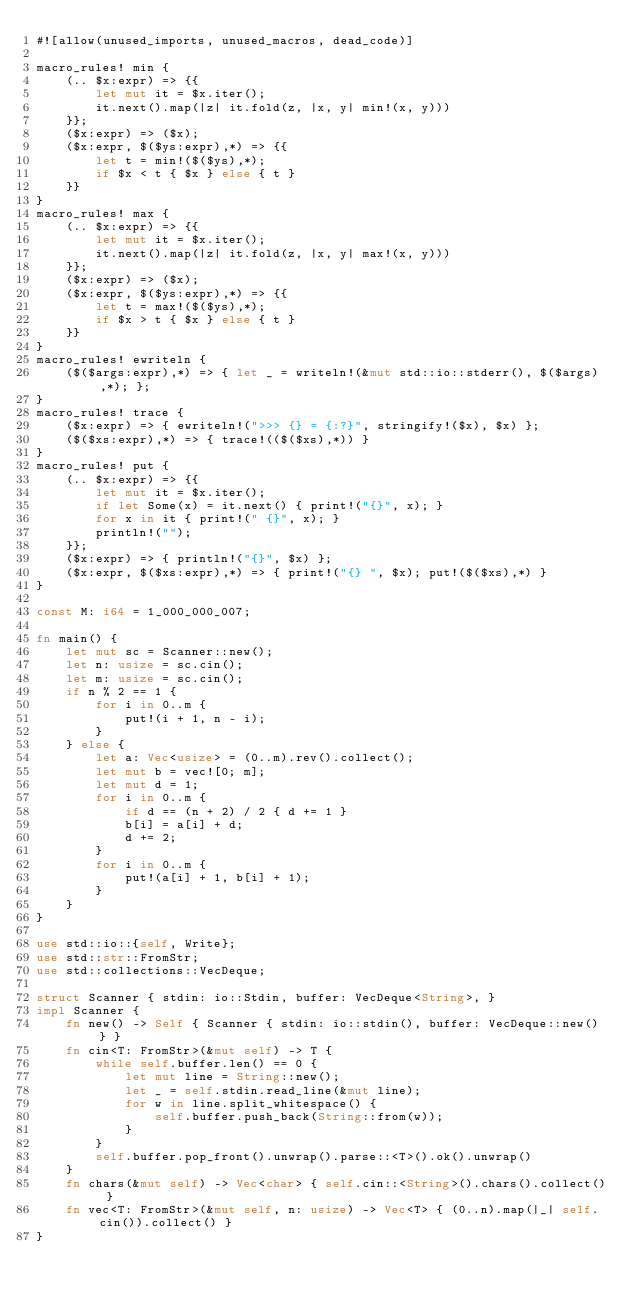Convert code to text. <code><loc_0><loc_0><loc_500><loc_500><_Rust_>#![allow(unused_imports, unused_macros, dead_code)]

macro_rules! min {
    (.. $x:expr) => {{
        let mut it = $x.iter();
        it.next().map(|z| it.fold(z, |x, y| min!(x, y)))
    }};
    ($x:expr) => ($x);
    ($x:expr, $($ys:expr),*) => {{
        let t = min!($($ys),*);
        if $x < t { $x } else { t }
    }}
}
macro_rules! max {
    (.. $x:expr) => {{
        let mut it = $x.iter();
        it.next().map(|z| it.fold(z, |x, y| max!(x, y)))
    }};
    ($x:expr) => ($x);
    ($x:expr, $($ys:expr),*) => {{
        let t = max!($($ys),*);
        if $x > t { $x } else { t }
    }}
}
macro_rules! ewriteln {
    ($($args:expr),*) => { let _ = writeln!(&mut std::io::stderr(), $($args),*); };
}
macro_rules! trace {
    ($x:expr) => { ewriteln!(">>> {} = {:?}", stringify!($x), $x) };
    ($($xs:expr),*) => { trace!(($($xs),*)) }
}
macro_rules! put {
    (.. $x:expr) => {{
        let mut it = $x.iter();
        if let Some(x) = it.next() { print!("{}", x); }
        for x in it { print!(" {}", x); }
        println!("");
    }};
    ($x:expr) => { println!("{}", $x) };
    ($x:expr, $($xs:expr),*) => { print!("{} ", $x); put!($($xs),*) }
}

const M: i64 = 1_000_000_007;

fn main() {
    let mut sc = Scanner::new();
    let n: usize = sc.cin();
    let m: usize = sc.cin();
    if n % 2 == 1 {
        for i in 0..m {
            put!(i + 1, n - i);
        }
    } else {
        let a: Vec<usize> = (0..m).rev().collect();
        let mut b = vec![0; m];
        let mut d = 1;
        for i in 0..m {
            if d == (n + 2) / 2 { d += 1 }
            b[i] = a[i] + d;
            d += 2;
        }
        for i in 0..m {
            put!(a[i] + 1, b[i] + 1);
        }
    }
}

use std::io::{self, Write};
use std::str::FromStr;
use std::collections::VecDeque;

struct Scanner { stdin: io::Stdin, buffer: VecDeque<String>, }
impl Scanner {
    fn new() -> Self { Scanner { stdin: io::stdin(), buffer: VecDeque::new() } }
    fn cin<T: FromStr>(&mut self) -> T {
        while self.buffer.len() == 0 {
            let mut line = String::new();
            let _ = self.stdin.read_line(&mut line);
            for w in line.split_whitespace() {
                self.buffer.push_back(String::from(w));
            }
        }
        self.buffer.pop_front().unwrap().parse::<T>().ok().unwrap()
    }
    fn chars(&mut self) -> Vec<char> { self.cin::<String>().chars().collect() }
    fn vec<T: FromStr>(&mut self, n: usize) -> Vec<T> { (0..n).map(|_| self.cin()).collect() }
}
</code> 